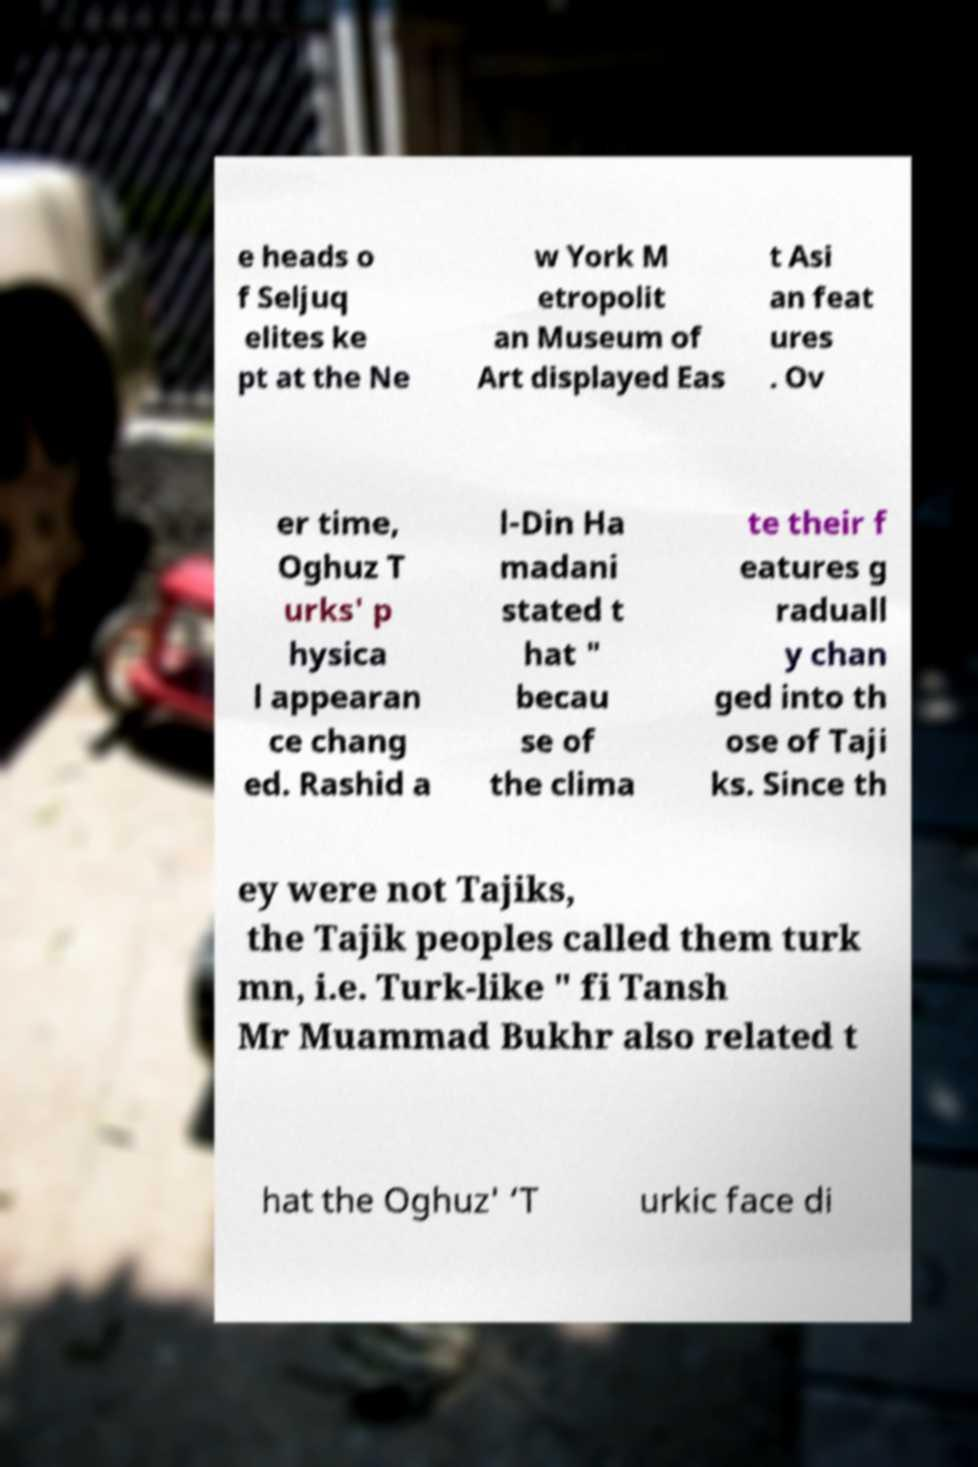Please identify and transcribe the text found in this image. e heads o f Seljuq elites ke pt at the Ne w York M etropolit an Museum of Art displayed Eas t Asi an feat ures . Ov er time, Oghuz T urks' p hysica l appearan ce chang ed. Rashid a l-Din Ha madani stated t hat " becau se of the clima te their f eatures g raduall y chan ged into th ose of Taji ks. Since th ey were not Tajiks, the Tajik peoples called them turk mn, i.e. Turk-like " fi Tansh Mr Muammad Bukhr also related t hat the Oghuz' ‘T urkic face di 